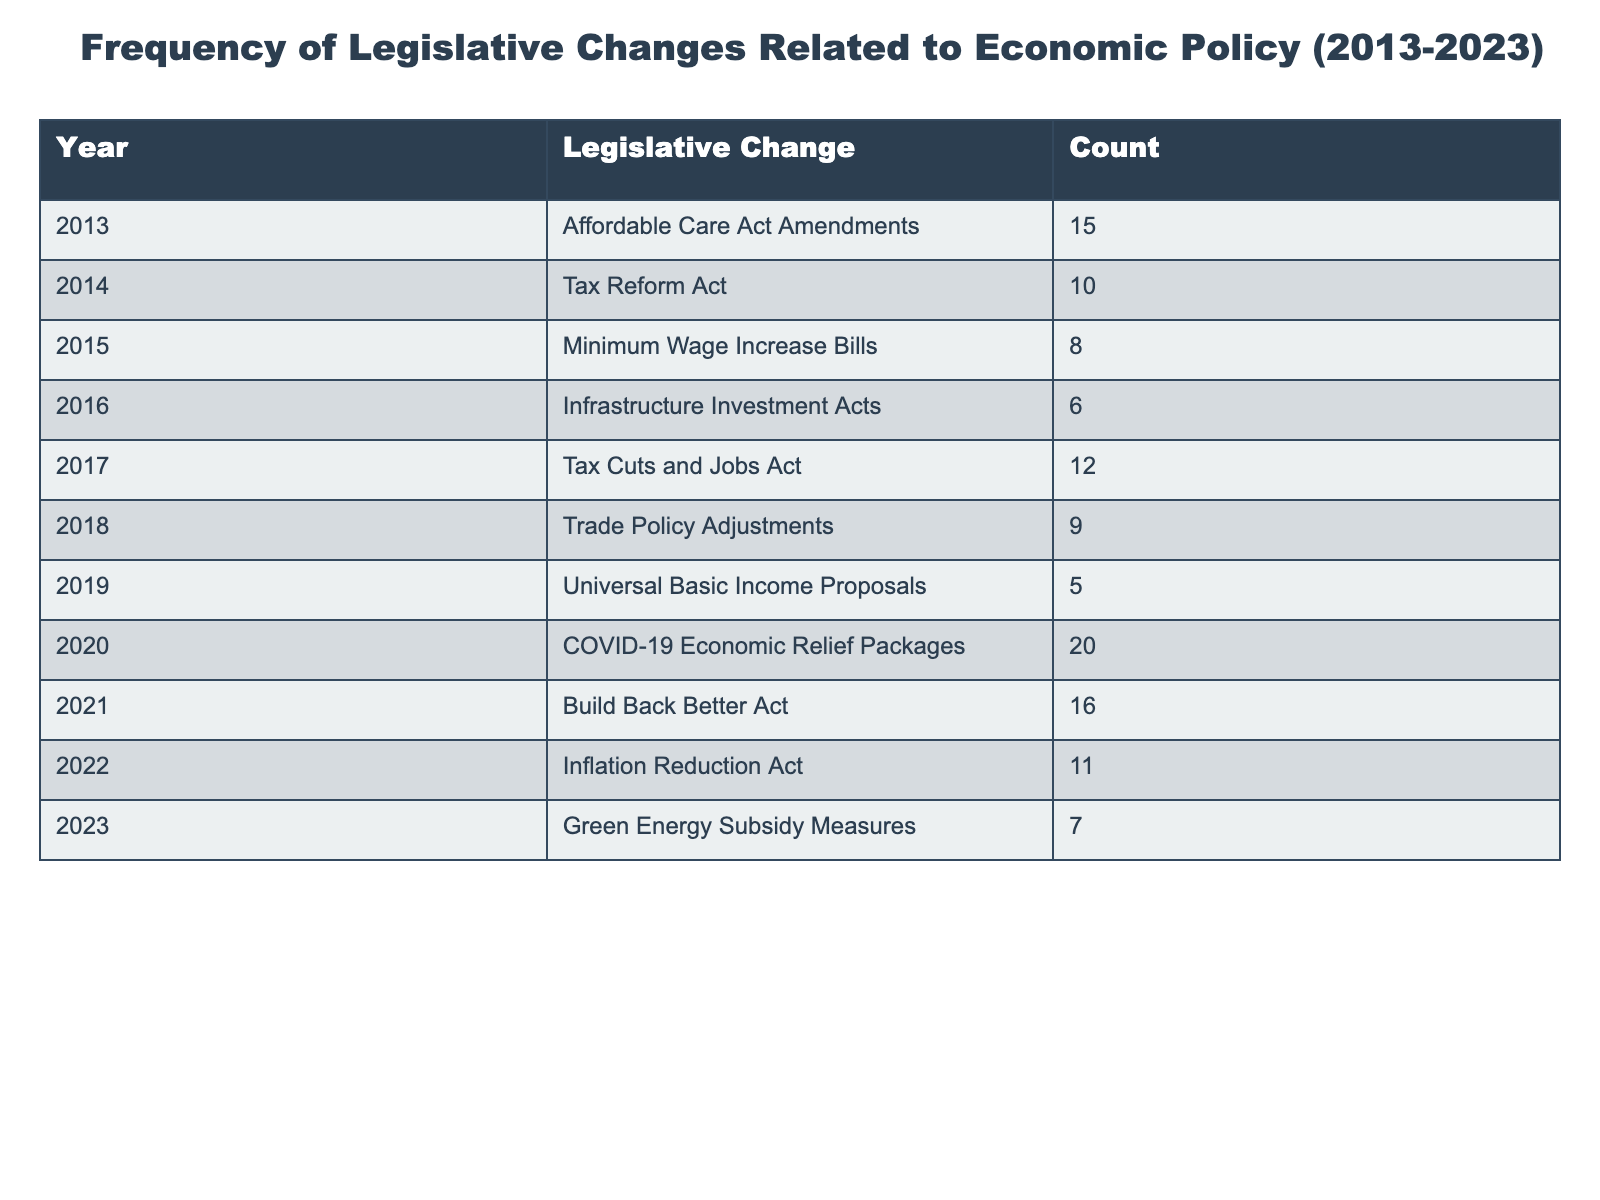What was the most frequent type of legislative change related to economic policy in the last decade? By examining the "Count" column in the table, we can identify that the "COVID-19 Economic Relief Packages" in 2020 has the highest count of 20, which indicates it was the most frequent type of legislative change during this period.
Answer: 20 How many legislative changes related to economic policy were implemented in 2015 and 2019 combined? First, we look at the counts for 2015, which is 8 (Minimum Wage Increase Bills), and for 2019, which is 5 (Universal Basic Income Proposals). Adding these two counts together gives us 8 + 5 = 13.
Answer: 13 Was there a legislative change related to economic policy in 2016? Looking at the table, we find that there was indeed a legislative change listed for 2016, which is the "Infrastructure Investment Acts." Therefore, the answer is yes.
Answer: Yes What is the difference in the number of legislative changes between 2020 and 2014? For 2020, the count is 20 (COVID-19 Economic Relief Packages), and for 2014, the count is 10 (Tax Reform Act). The difference is calculated as 20 - 10 = 10.
Answer: 10 What is the average number of legislative changes per year over the decade? To find the average, we need to sum all counts: 15 + 10 + 8 + 6 + 12 + 9 + 5 + 20 + 16 + 11 + 7 = 119. There are 11 years (from 2013 to 2023), so the average is 119 / 11 ≈ 10.82, rounded to two decimal places.
Answer: 10.82 How many legislative changes had a count greater than 10? By examining the table, the counts greater than 10 are from the years 2020 (20), 2021 (16), and 2017 (12). Thus, there are 3 changes that fit this criterion.
Answer: 3 Did the number of legislative changes increase consistently every year? To determine if there was a consistent increase, we can look at the "Count" values year by year and note the fluctuations. The table shows that there were years with both increases and decreases, specifically between 2018 and 2019 and 2022 and 2023. Thus, the answer is no.
Answer: No What was the total number of legislative changes from 2013 to 2022? We sum the counts for each year up to 2022: 15 + 10 + 8 + 6 + 12 + 9 + 5 + 20 + 16 + 11 = 112.
Answer: 112 How many years had fewer than 10 legislative changes? Looking through the counts, we find that the years with counts less than 10 are 2015 (8), 2016 (6), and 2019 (5). Thus, there are 3 such years.
Answer: 3 